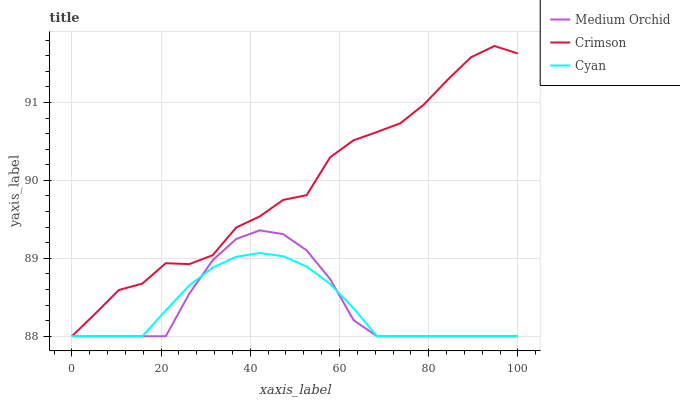Does Medium Orchid have the minimum area under the curve?
Answer yes or no. No. Does Medium Orchid have the maximum area under the curve?
Answer yes or no. No. Is Medium Orchid the smoothest?
Answer yes or no. No. Is Medium Orchid the roughest?
Answer yes or no. No. Does Medium Orchid have the highest value?
Answer yes or no. No. 